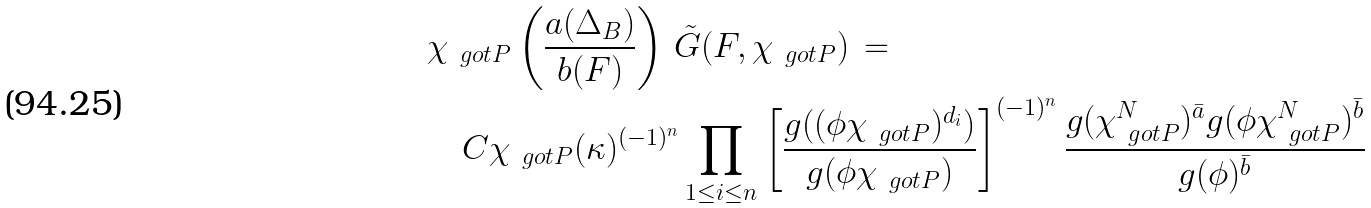<formula> <loc_0><loc_0><loc_500><loc_500>& \chi _ { \ g o t P } \left ( \frac { a ( \Delta _ { B } ) } { b ( F ) } \right ) \, \tilde { G } ( F , \chi _ { \ g o t P } ) \, = \\ & \quad C \chi _ { \ g o t P } ( \kappa ) ^ { ( - 1 ) ^ { n } } \prod _ { 1 \leq i \leq n } \left [ \frac { g ( ( \phi \chi _ { \ g o t P } ) ^ { d _ { i } } ) } { g ( \phi \chi _ { \ g o t P } ) } \right ] ^ { ( - 1 ) ^ { n } } \frac { g ( \chi _ { \ g o t P } ^ { N } ) ^ { \bar { a } } g ( \phi \chi _ { \ g o t P } ^ { N } ) ^ { \bar { b } } } { g ( \phi ) ^ { \bar { b } } }</formula> 